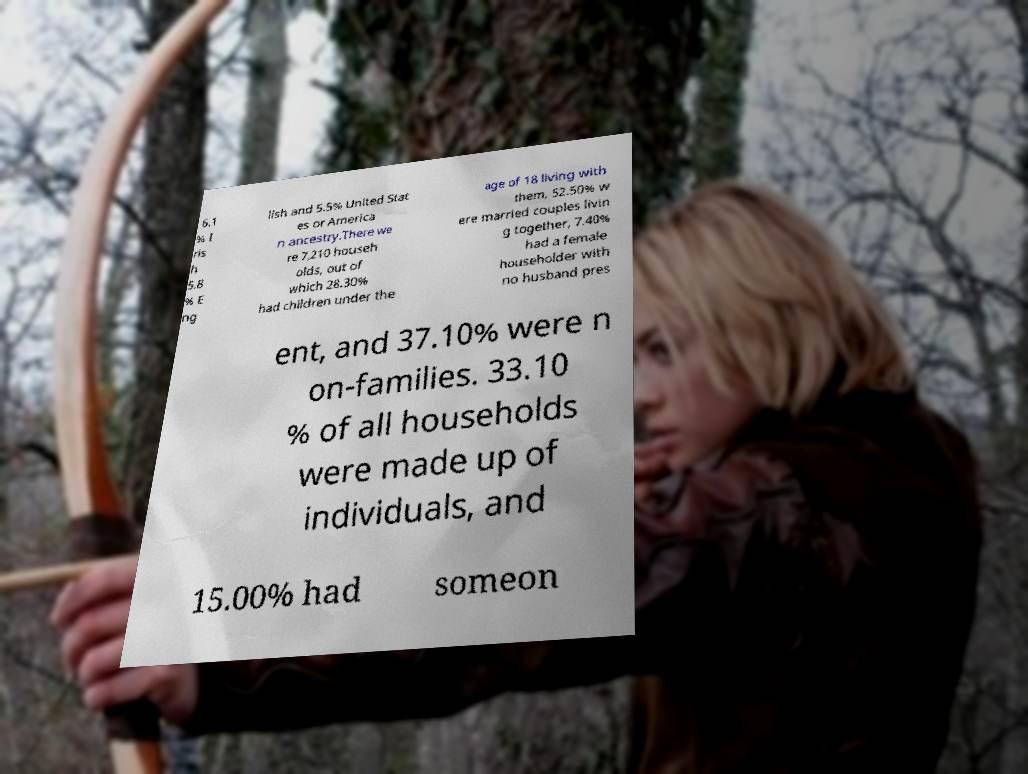Can you accurately transcribe the text from the provided image for me? 6.1 % I ris h 5.8 % E ng lish and 5.5% United Stat es or America n ancestry.There we re 7,210 househ olds, out of which 28.30% had children under the age of 18 living with them, 52.50% w ere married couples livin g together, 7.40% had a female householder with no husband pres ent, and 37.10% were n on-families. 33.10 % of all households were made up of individuals, and 15.00% had someon 